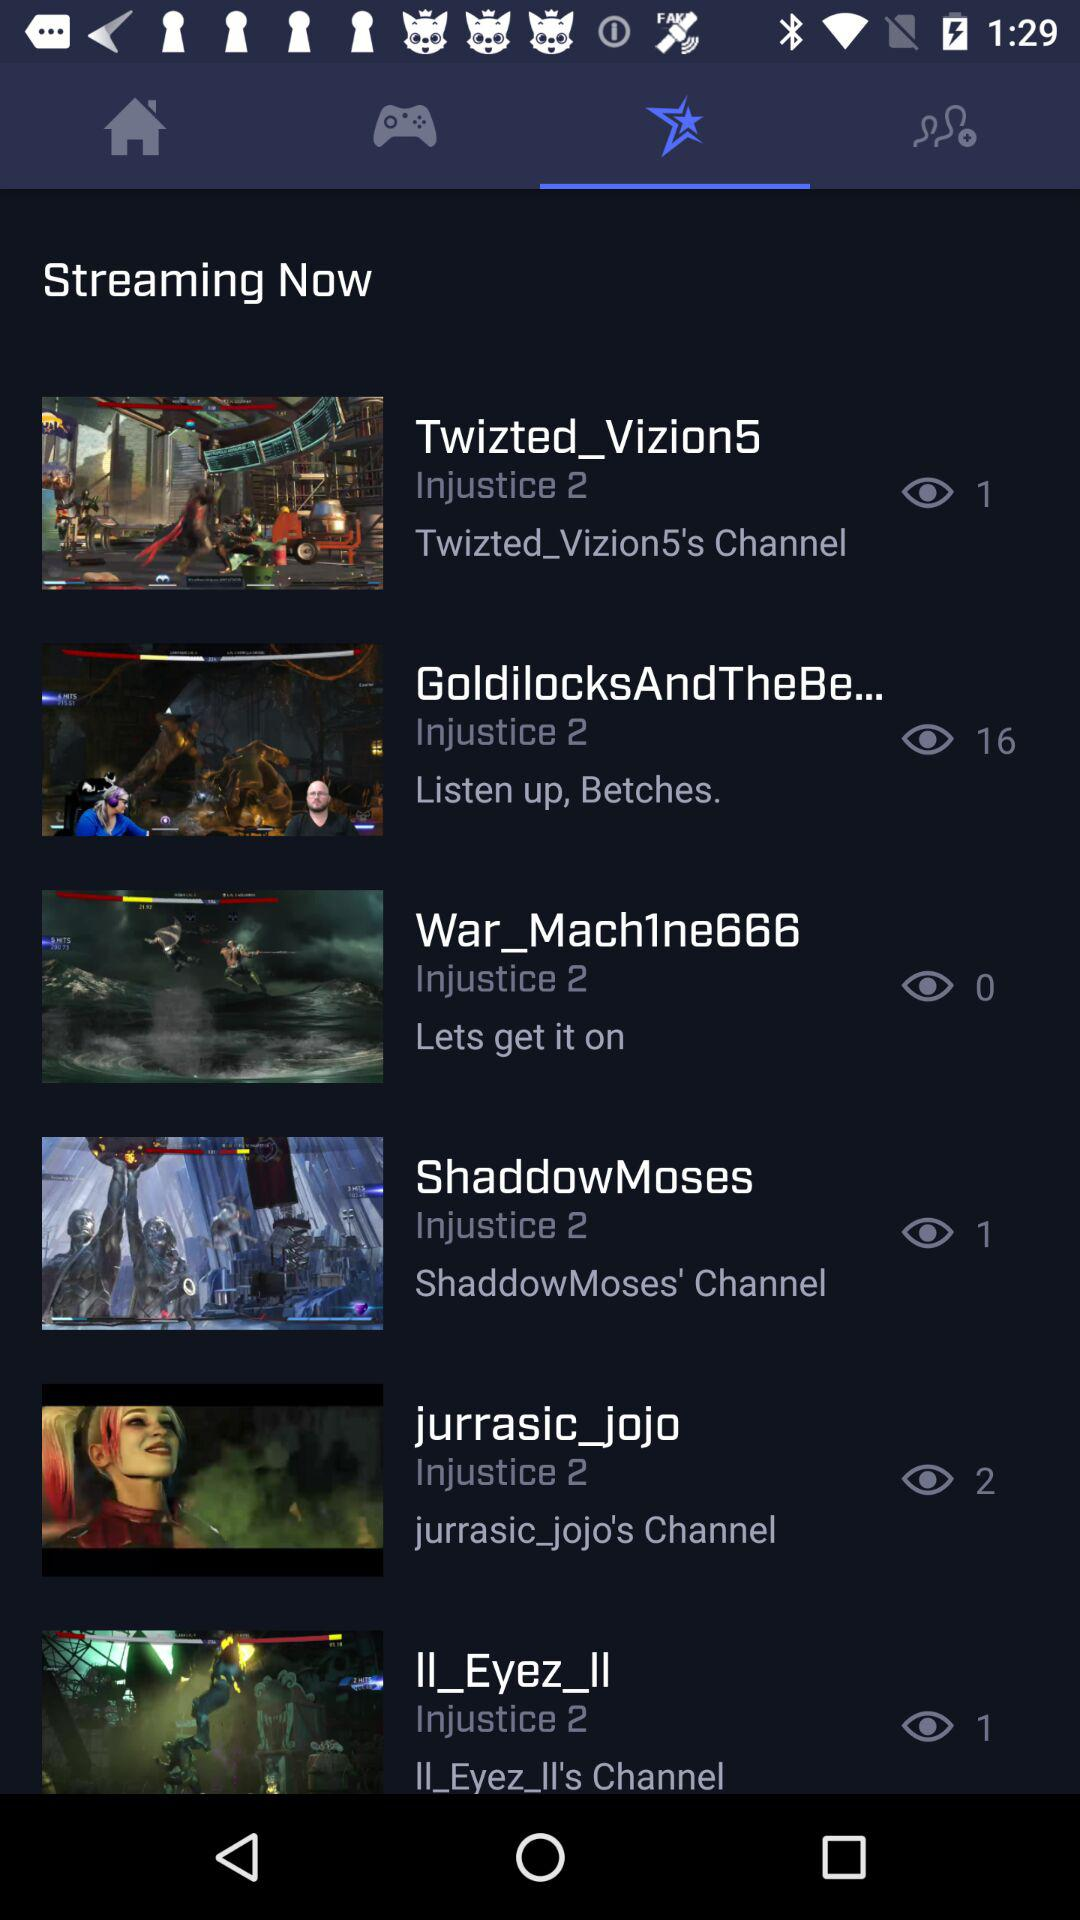How many views are there on "ShaddowMoses"? There is 1 view on "ShaddowMoses". 